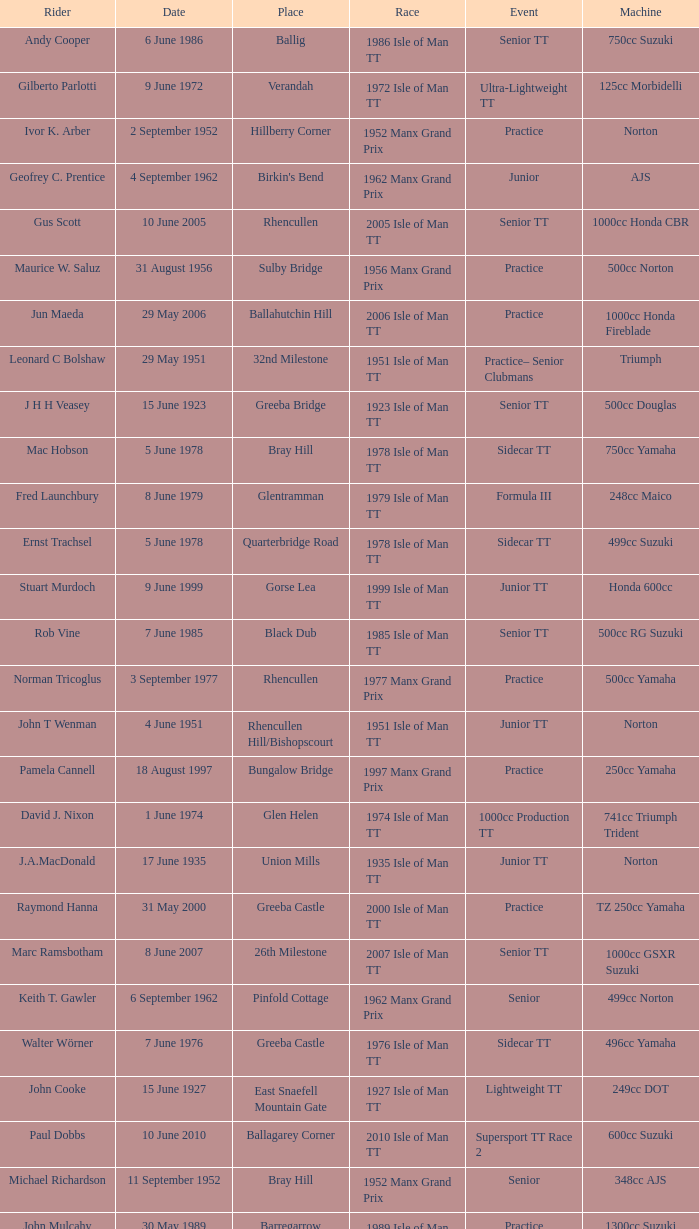What machine did Keith T. Gawler ride? 499cc Norton. 